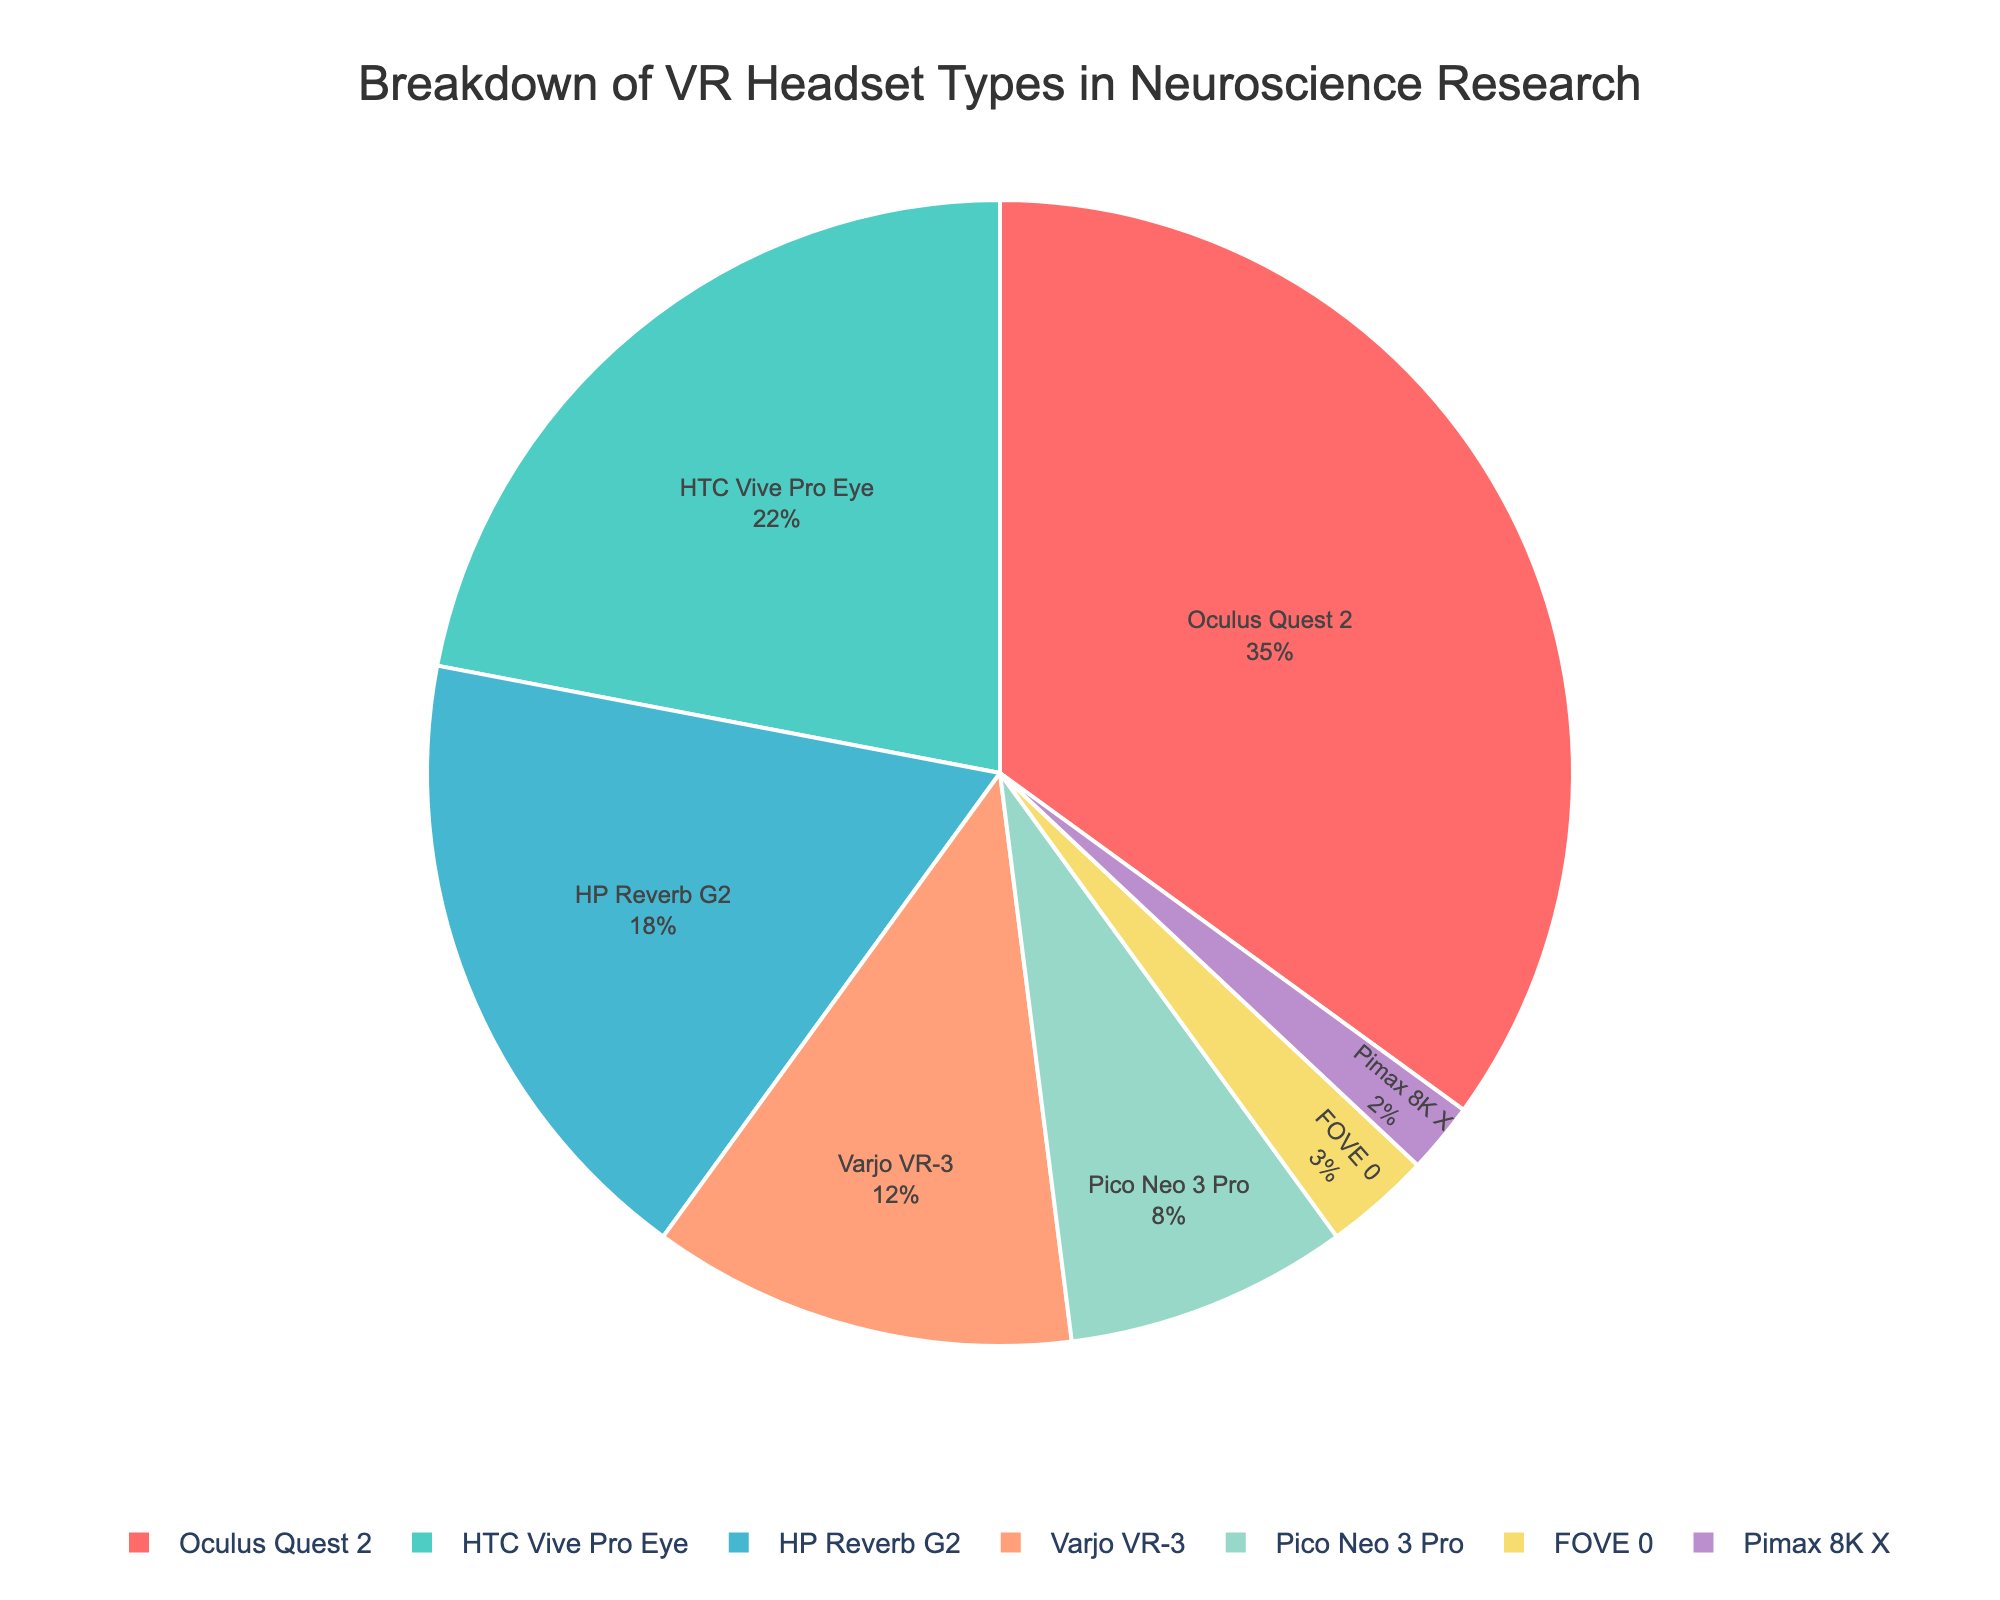Which VR headset type is the most used in neuroscience research? The figure shows that the Oculus Quest 2 has the largest slice in the pie chart with a 35% usage rate.
Answer: Oculus Quest 2 Which two VR headset types combined use exceeds 40% in neuroscience research? Adding the percentages of HTC Vive Pro Eye (22%) and HP Reverb G2 (18%) exceeds 40%.
Answer: HTC Vive Pro Eye and HP Reverb G2 What is the percentage difference between the most used and the least used VR headset types in neuroscience research? Subtracting the least percentage (Pimax 8K X, 2%) from the most percentage (Oculus Quest 2, 35%) gives the difference. 35% - 2% = 33%.
Answer: 33% What fraction of the total usage do the top three VR headset types constitute? Adding the percentages of Oculus Quest 2 (35%), HTC Vive Pro Eye (22%), and HP Reverb G2 (18%) gives a total of 75%.
Answer: 75% If another study showed that 5% of unspecified headsets were used, what would be the new percentage for Oculus Quest 2, given it retains the same count? The total percentages now sum to 105%. Recalculating Oculus Quest 2's percentage, (35/105) * 100 gives the new percentage. (35/105) * 100 = 33.3%.
Answer: 33.3% How does the percentage of the Pico Neo 3 Pro compare with the average percentage of all the other headsets? Excluding Pico Neo 3 Pro (8%), the total of the other percentages is 92%. The average percentage of the other six headsets: 92/6 ≈ 15.33%. Compare 8% with 15.33%.
Answer: Pico Neo 3 Pro is less than the average Which headset types use more than three times the usage of the FOVE 0? FOVE 0 usage is 3%, so three times is 9%. Headsets with higher percentages than 9% are Oculus Quest 2 (35%), HTC Vive Pro Eye (22%), HP Reverb G2 (18%), and Varjo VR-3 (12%).
Answer: Oculus Quest 2, HTC Vive Pro Eye, HP Reverb G2, Varjo VR-3 Is the combined usage of the less popular headsets (Pico Neo 3 Pro, FOVE 0, Pimax 8K X) greater than 20%? Adding their percentages: Pico Neo 3 Pro (8%) + FOVE 0 (3%) + Pimax 8K X (2%) equals 13%.
Answer: No How does the Varjo VR-3's usage compare to the combined usage of FOVE 0 and Pimax 8K X? Varjo VR-3 has 12%, and the combined percentage of FOVE 0 and Pimax 8K X is 3% + 2% = 5%.
Answer: Varjo VR-3 is greater Which slice in the pie chart is represented by the yellow color? The yellow slice in the pie chart corresponds to the HP Reverb G2 with 18%.
Answer: HP Reverb G2 